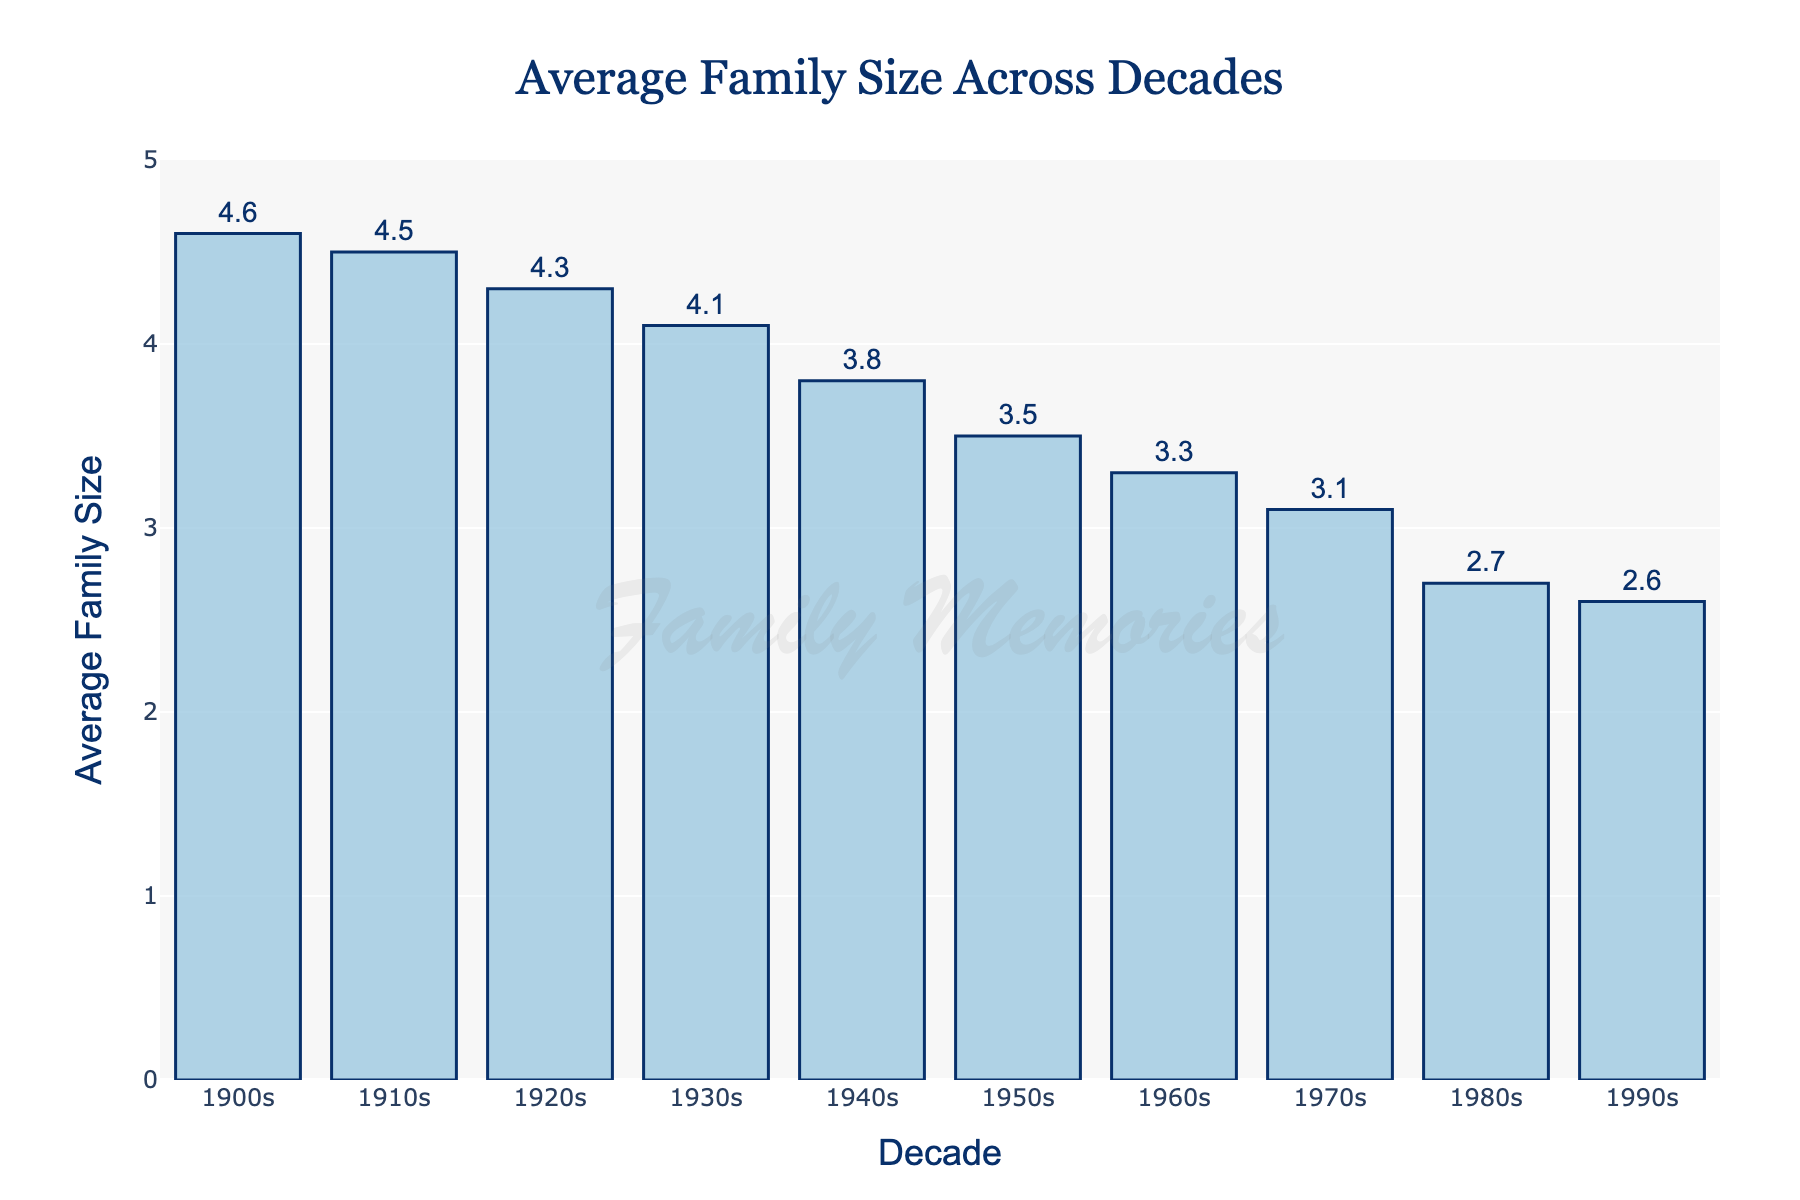Which decade had the largest average family size? The chart shows that the highest bar corresponds to the 1900s, indicating the largest average family size.
Answer: 1900s How did the average family size change from the 1900s to the 1990s? To determine the change, subtract the average family size in the 1990s (2.6) from that in the 1900s (4.6): 4.6 - 2.6. Thus, the average family size decreased by 2.
Answer: Decreased by 2 Which decade had the smallest average family size? The chart shows that the lowest bar corresponds to the 1990s, indicating the smallest average family size.
Answer: 1990s What is the difference in average family size between the 1940s and 1970s? The average family size in the 1940s is 3.8, and in the 1970s it is 3.1. The difference is 3.8 - 3.1.
Answer: 0.7 Which two decades have the same overall trend in the average family size? All decades show a decreasing trend in average family size without any exceptions.
Answer: All decades Compare the average family size in the 1910s and the 1960s. The bar for the 1910s shows an average family size of 4.5, whereas the bar for the 1960s shows 3.3. Comparatively, the average family size decreased from the 1910s to the 1960s.
Answer: 1910s had larger family size Which decade had an average family size closer to 4.0? By examining the chart, we see the 1930s had an average family size of 4.1, which is closest to 4.0.
Answer: 1930s What was the most prominent visual trend in the chart? The chart visually indicates a steady decline in the average family size from the 1900s to the 1990s, with each successive bar being shorter than the previous one.
Answer: Decline in average family size Calculate the average family size over the entire century. Sum all the average family sizes: 4.6 + 4.5 + 4.3 + 4.1 + 3.8 + 3.5 + 3.3 + 3.1 + 2.7 + 2.6 = 36.5. Divide by the number of decades: 36.5 / 10.
Answer: 3.65 